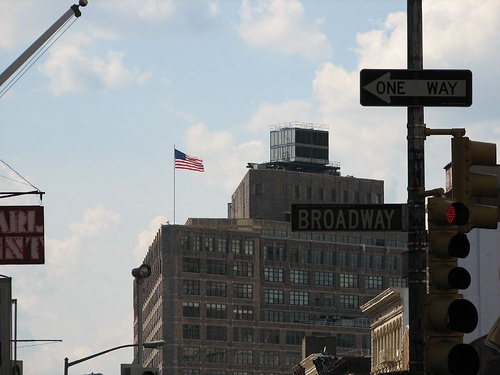Describe the objects in this image and their specific colors. I can see a traffic light in lightgray, black, gray, maroon, and brown tones in this image. 